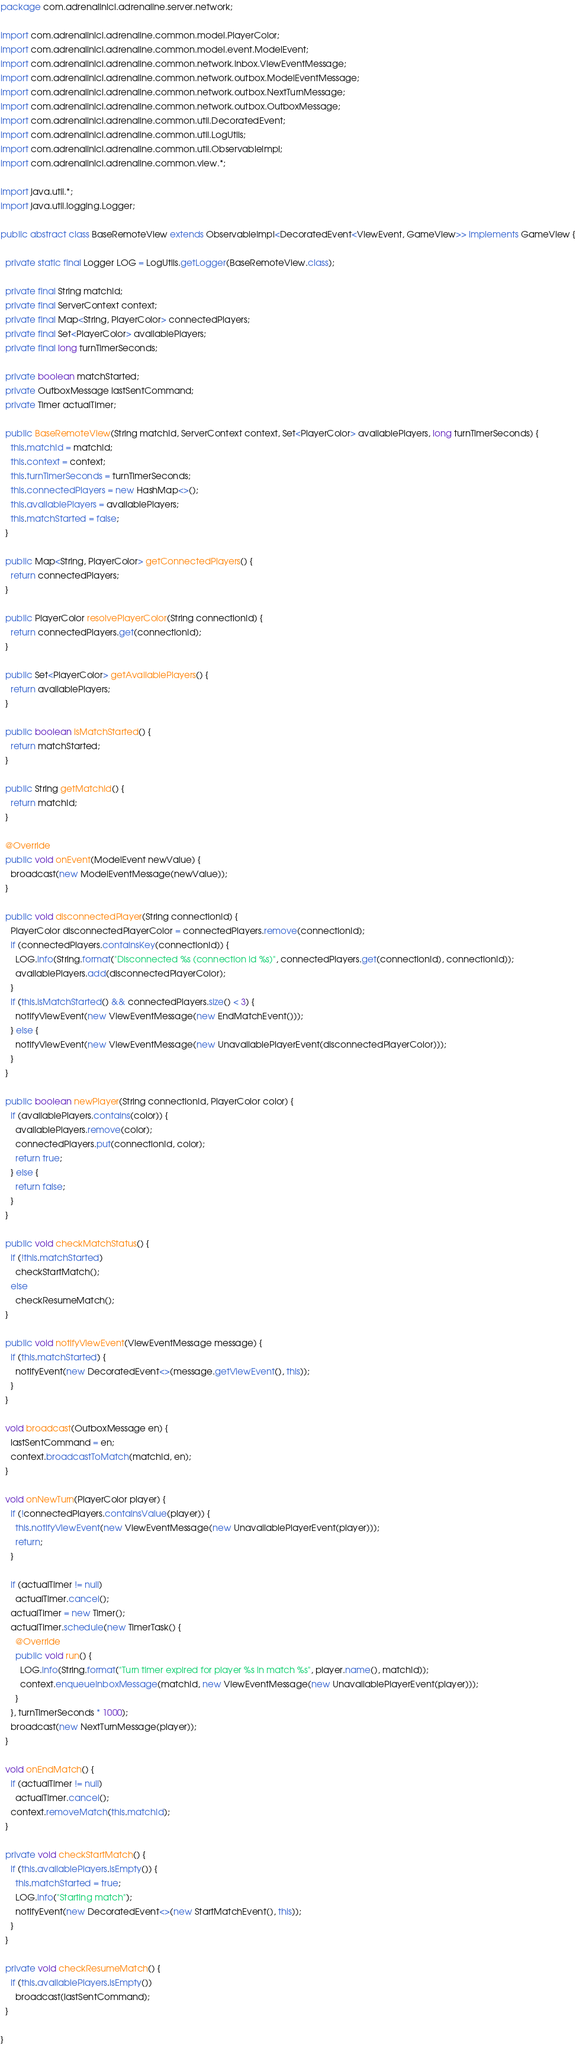Convert code to text. <code><loc_0><loc_0><loc_500><loc_500><_Java_>package com.adrenalinici.adrenaline.server.network;

import com.adrenalinici.adrenaline.common.model.PlayerColor;
import com.adrenalinici.adrenaline.common.model.event.ModelEvent;
import com.adrenalinici.adrenaline.common.network.inbox.ViewEventMessage;
import com.adrenalinici.adrenaline.common.network.outbox.ModelEventMessage;
import com.adrenalinici.adrenaline.common.network.outbox.NextTurnMessage;
import com.adrenalinici.adrenaline.common.network.outbox.OutboxMessage;
import com.adrenalinici.adrenaline.common.util.DecoratedEvent;
import com.adrenalinici.adrenaline.common.util.LogUtils;
import com.adrenalinici.adrenaline.common.util.ObservableImpl;
import com.adrenalinici.adrenaline.common.view.*;

import java.util.*;
import java.util.logging.Logger;

public abstract class BaseRemoteView extends ObservableImpl<DecoratedEvent<ViewEvent, GameView>> implements GameView {

  private static final Logger LOG = LogUtils.getLogger(BaseRemoteView.class);

  private final String matchId;
  private final ServerContext context;
  private final Map<String, PlayerColor> connectedPlayers;
  private final Set<PlayerColor> availablePlayers;
  private final long turnTimerSeconds;

  private boolean matchStarted;
  private OutboxMessage lastSentCommand;
  private Timer actualTimer;

  public BaseRemoteView(String matchId, ServerContext context, Set<PlayerColor> availablePlayers, long turnTimerSeconds) {
    this.matchId = matchId;
    this.context = context;
    this.turnTimerSeconds = turnTimerSeconds;
    this.connectedPlayers = new HashMap<>();
    this.availablePlayers = availablePlayers;
    this.matchStarted = false;
  }

  public Map<String, PlayerColor> getConnectedPlayers() {
    return connectedPlayers;
  }

  public PlayerColor resolvePlayerColor(String connectionId) {
    return connectedPlayers.get(connectionId);
  }

  public Set<PlayerColor> getAvailablePlayers() {
    return availablePlayers;
  }

  public boolean isMatchStarted() {
    return matchStarted;
  }

  public String getMatchId() {
    return matchId;
  }

  @Override
  public void onEvent(ModelEvent newValue) {
    broadcast(new ModelEventMessage(newValue));
  }

  public void disconnectedPlayer(String connectionId) {
    PlayerColor disconnectedPlayerColor = connectedPlayers.remove(connectionId);
    if (connectedPlayers.containsKey(connectionId)) {
      LOG.info(String.format("Disconnected %s (connection id %s)", connectedPlayers.get(connectionId), connectionId));
      availablePlayers.add(disconnectedPlayerColor);
    }
    if (this.isMatchStarted() && connectedPlayers.size() < 3) {
      notifyViewEvent(new ViewEventMessage(new EndMatchEvent()));
    } else {
      notifyViewEvent(new ViewEventMessage(new UnavailablePlayerEvent(disconnectedPlayerColor)));
    }
  }

  public boolean newPlayer(String connectionId, PlayerColor color) {
    if (availablePlayers.contains(color)) {
      availablePlayers.remove(color);
      connectedPlayers.put(connectionId, color);
      return true;
    } else {
      return false;
    }
  }

  public void checkMatchStatus() {
    if (!this.matchStarted)
      checkStartMatch();
    else
      checkResumeMatch();
  }

  public void notifyViewEvent(ViewEventMessage message) {
    if (this.matchStarted) {
      notifyEvent(new DecoratedEvent<>(message.getViewEvent(), this));
    }
  }

  void broadcast(OutboxMessage en) {
    lastSentCommand = en;
    context.broadcastToMatch(matchId, en);
  }

  void onNewTurn(PlayerColor player) {
    if (!connectedPlayers.containsValue(player)) {
      this.notifyViewEvent(new ViewEventMessage(new UnavailablePlayerEvent(player)));
      return;
    }

    if (actualTimer != null)
      actualTimer.cancel();
    actualTimer = new Timer();
    actualTimer.schedule(new TimerTask() {
      @Override
      public void run() {
        LOG.info(String.format("Turn timer expired for player %s in match %s", player.name(), matchId));
        context.enqueueInboxMessage(matchId, new ViewEventMessage(new UnavailablePlayerEvent(player)));
      }
    }, turnTimerSeconds * 1000);
    broadcast(new NextTurnMessage(player));
  }

  void onEndMatch() {
    if (actualTimer != null)
      actualTimer.cancel();
    context.removeMatch(this.matchId);
  }

  private void checkStartMatch() {
    if (this.availablePlayers.isEmpty()) {
      this.matchStarted = true;
      LOG.info("Starting match");
      notifyEvent(new DecoratedEvent<>(new StartMatchEvent(), this));
    }
  }

  private void checkResumeMatch() {
    if (this.availablePlayers.isEmpty())
      broadcast(lastSentCommand);
  }

}
</code> 